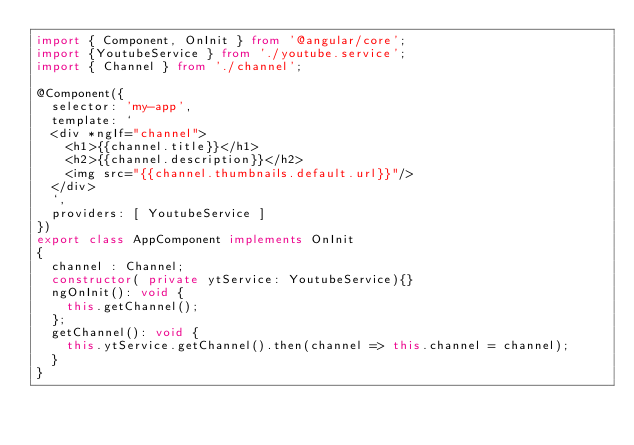<code> <loc_0><loc_0><loc_500><loc_500><_TypeScript_>import { Component, OnInit } from '@angular/core';
import {YoutubeService } from './youtube.service';
import { Channel } from './channel';

@Component({
  selector: 'my-app',
  template: `
  <div *ngIf="channel">
    <h1>{{channel.title}}</h1>
    <h2>{{channel.description}}</h2>
    <img src="{{channel.thumbnails.default.url}}"/>
  </div>
  `,
  providers: [ YoutubeService ]
})
export class AppComponent implements OnInit 
{ 
  channel : Channel;
  constructor( private ytService: YoutubeService){}
  ngOnInit(): void {
    this.getChannel();
  };
  getChannel(): void {
    this.ytService.getChannel().then(channel => this.channel = channel);
  }
}
</code> 